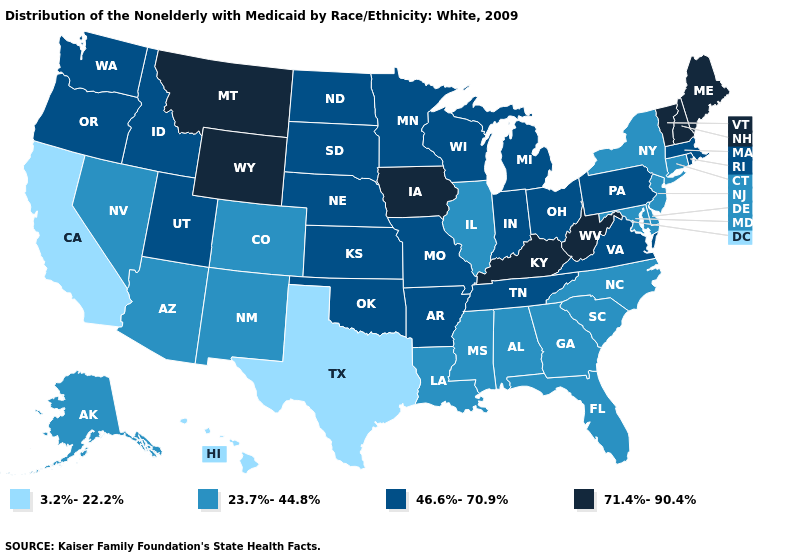What is the value of California?
Write a very short answer. 3.2%-22.2%. What is the highest value in the USA?
Be succinct. 71.4%-90.4%. How many symbols are there in the legend?
Answer briefly. 4. Which states have the lowest value in the USA?
Write a very short answer. California, Hawaii, Texas. Does Maryland have the same value as Massachusetts?
Answer briefly. No. What is the highest value in states that border Missouri?
Give a very brief answer. 71.4%-90.4%. What is the highest value in the USA?
Short answer required. 71.4%-90.4%. What is the highest value in states that border Kentucky?
Give a very brief answer. 71.4%-90.4%. Does Rhode Island have the lowest value in the USA?
Keep it brief. No. Does the map have missing data?
Answer briefly. No. Which states hav the highest value in the MidWest?
Give a very brief answer. Iowa. Among the states that border Texas , which have the lowest value?
Answer briefly. Louisiana, New Mexico. Name the states that have a value in the range 3.2%-22.2%?
Give a very brief answer. California, Hawaii, Texas. How many symbols are there in the legend?
Be succinct. 4. Does the first symbol in the legend represent the smallest category?
Short answer required. Yes. 